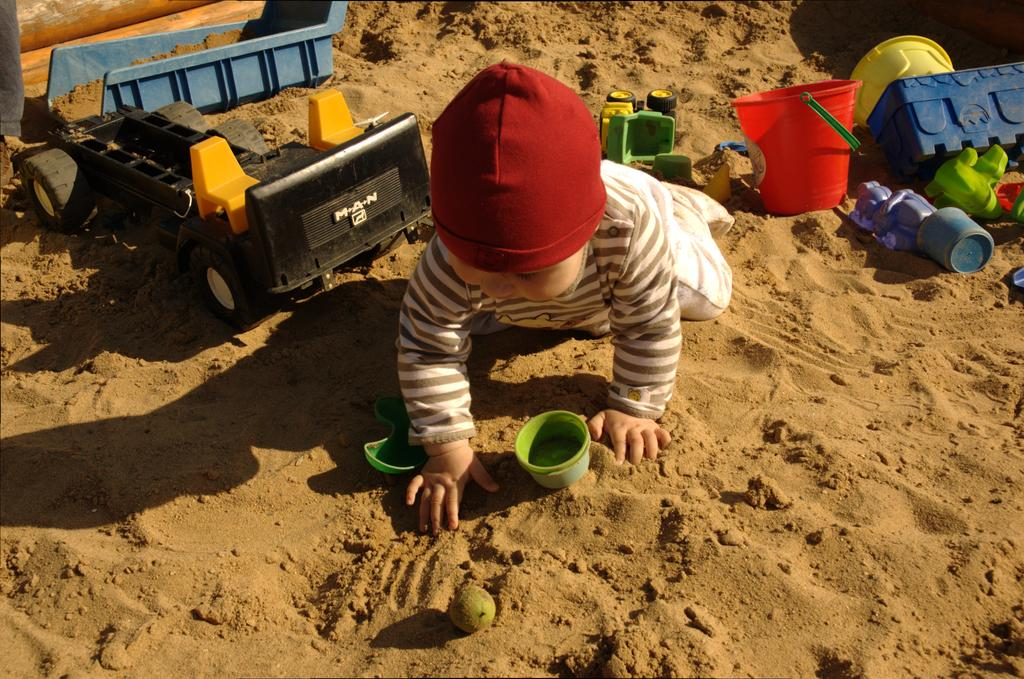What is the person in the image doing? The person is playing in the image. Where is the person playing? The person is playing on the sand. What else can be seen in the background of the image? There are toys visible in the background of the image. What type of camera is the dad using to capture the person playing in the image? There is no camera or dad present in the image; it only shows a person playing on the sand with toys visible in the background. 